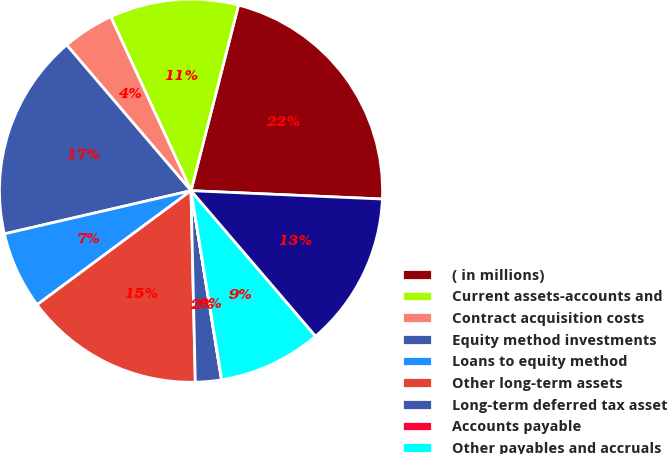<chart> <loc_0><loc_0><loc_500><loc_500><pie_chart><fcel>( in millions)<fcel>Current assets-accounts and<fcel>Contract acquisition costs<fcel>Equity method investments<fcel>Loans to equity method<fcel>Other long-term assets<fcel>Long-term deferred tax asset<fcel>Accounts payable<fcel>Other payables and accruals<fcel>Other long-term liabilities<nl><fcel>21.71%<fcel>10.87%<fcel>4.36%<fcel>17.38%<fcel>6.53%<fcel>15.21%<fcel>2.19%<fcel>0.02%<fcel>8.7%<fcel>13.04%<nl></chart> 